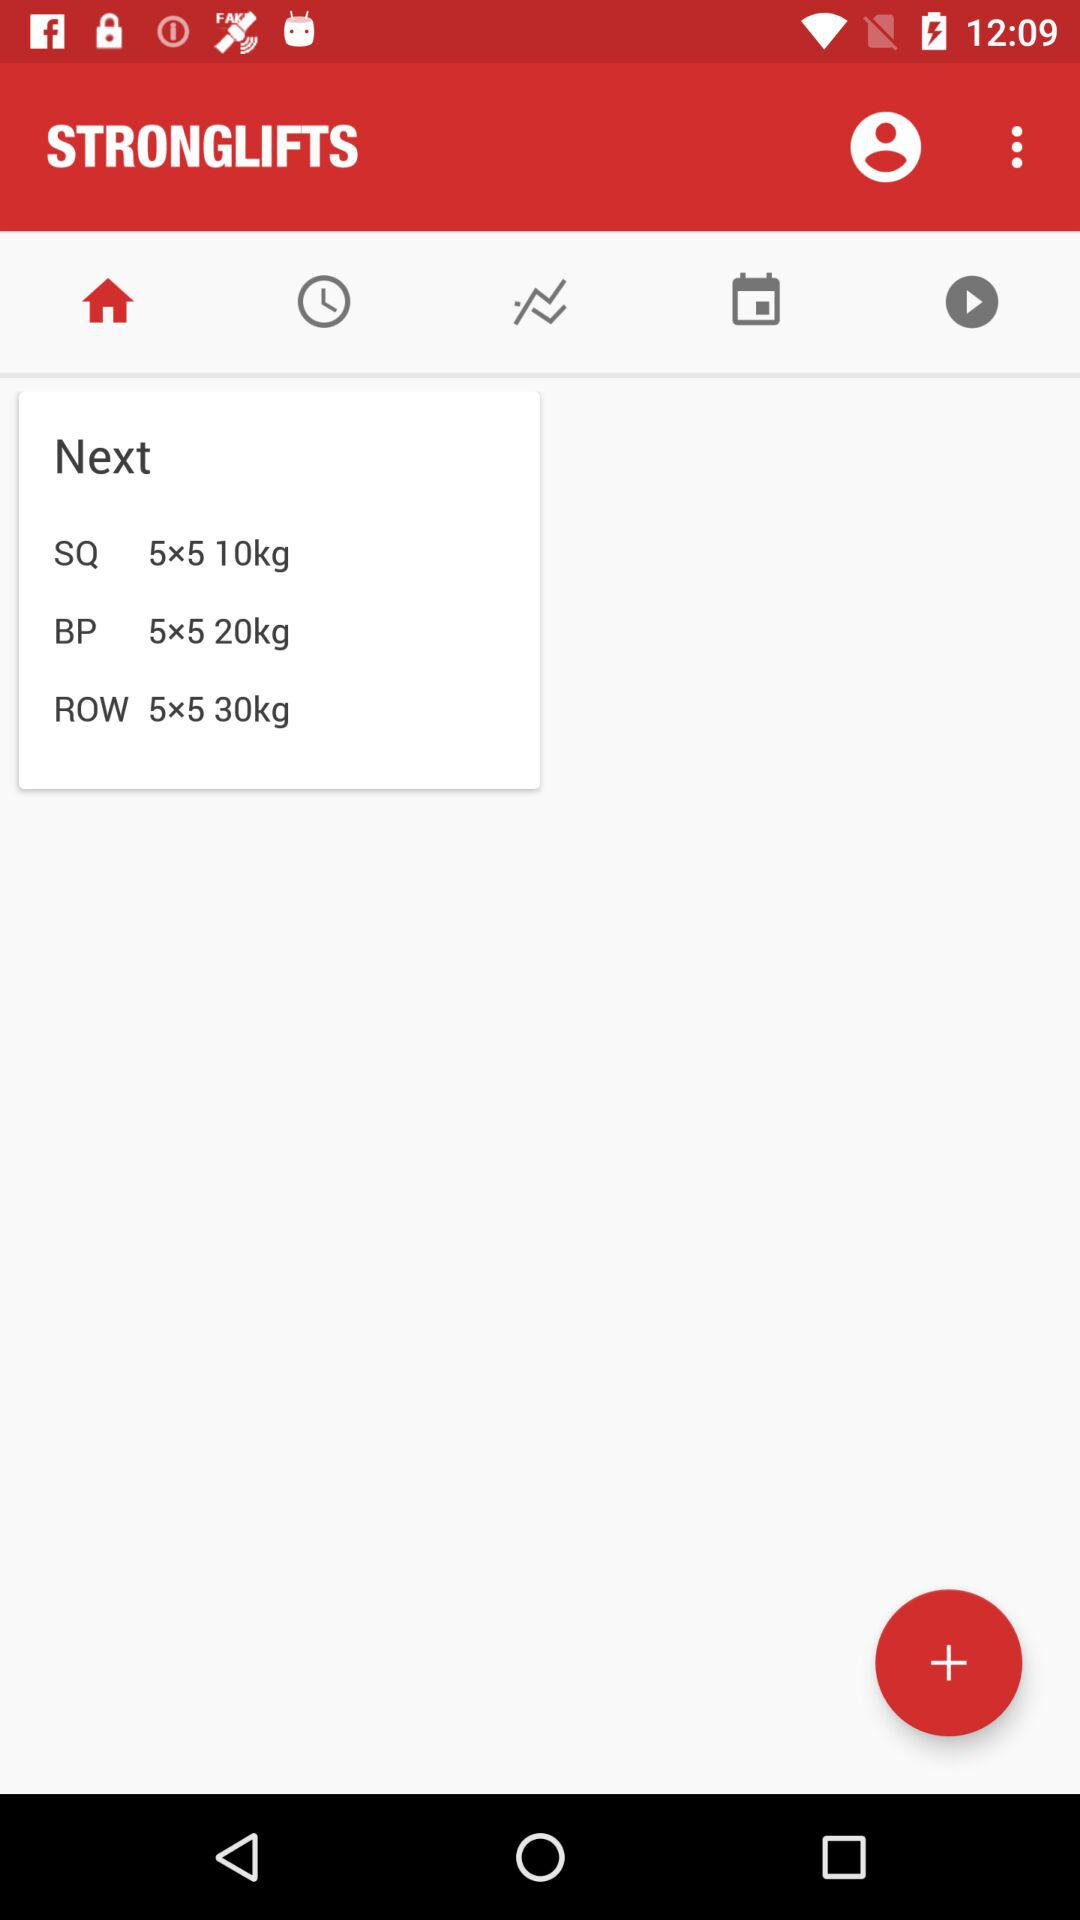What is mentioned for the "ROW"? For the "ROW", "5×5 30kg" is mentioned. 